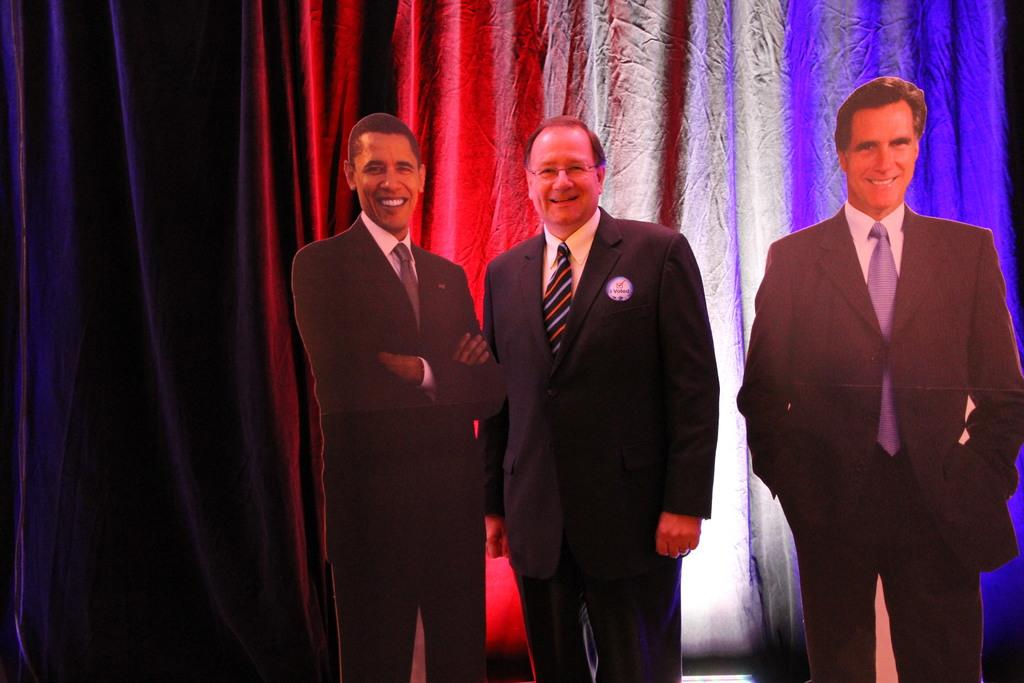What is the main subject of the image? There is a person standing in the image. Can you describe the person's position in relation to the objects around them? The person is standing between two boards. What can be seen in the background of the image? There is a curtain in the background of the image. What type of note is the person holding in the image? There is no note present in the image; the person is standing between two boards. How many cents can be seen on the person's scarf in the image? There is no scarf or mention of cents in the image; the person is standing between two boards. 